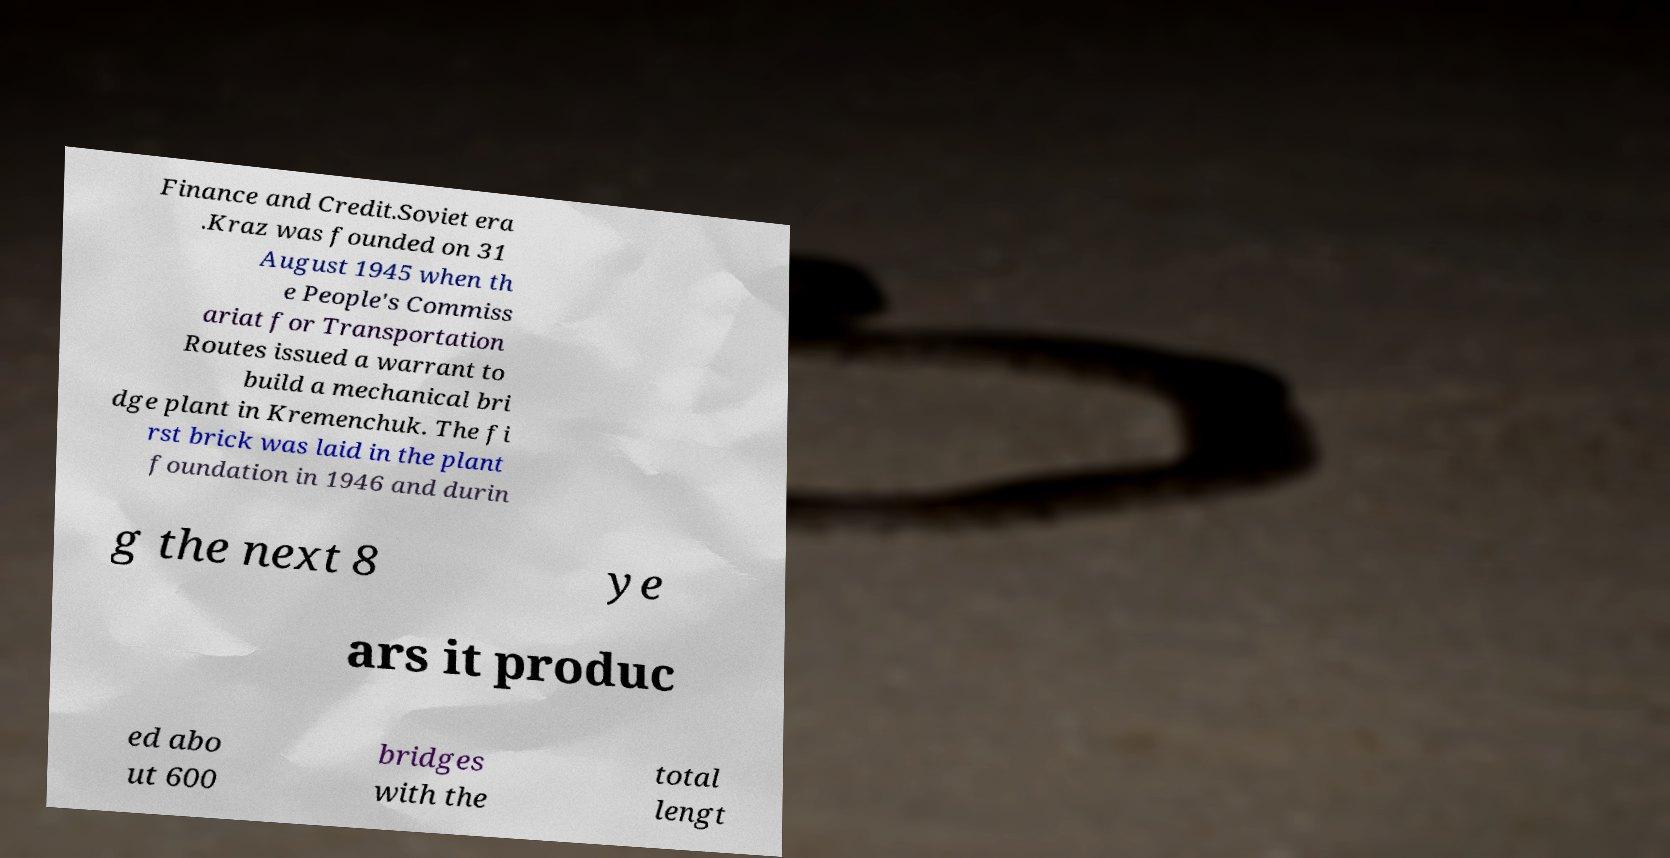I need the written content from this picture converted into text. Can you do that? Finance and Credit.Soviet era .Kraz was founded on 31 August 1945 when th e People's Commiss ariat for Transportation Routes issued a warrant to build a mechanical bri dge plant in Kremenchuk. The fi rst brick was laid in the plant foundation in 1946 and durin g the next 8 ye ars it produc ed abo ut 600 bridges with the total lengt 